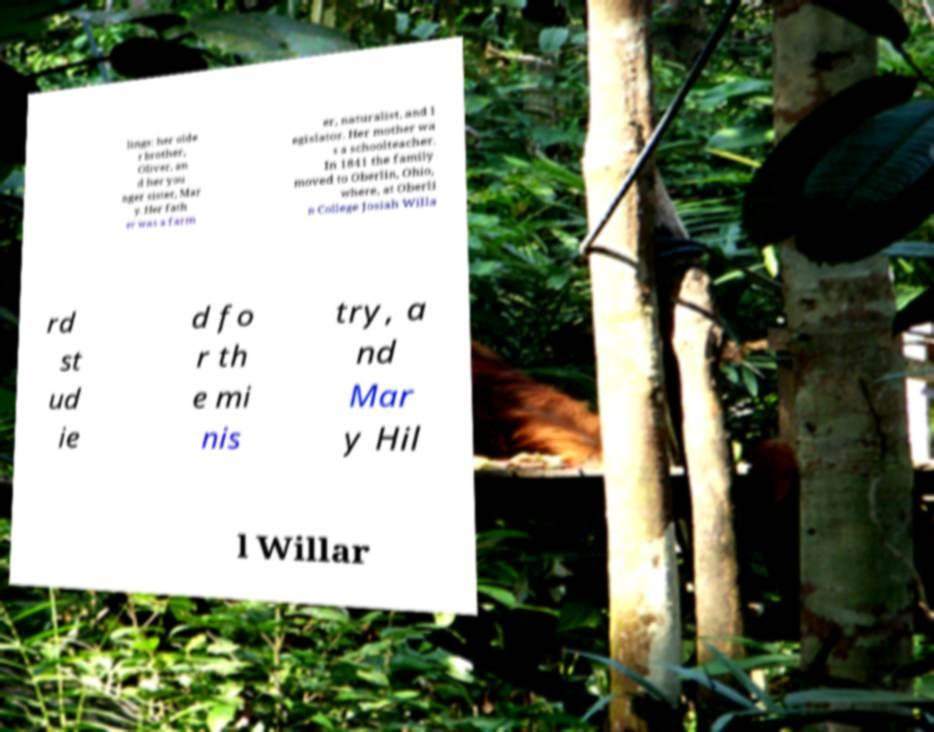I need the written content from this picture converted into text. Can you do that? lings: her olde r brother, Oliver, an d her you nger sister, Mar y. Her fath er was a farm er, naturalist, and l egislator. Her mother wa s a schoolteacher. In 1841 the family moved to Oberlin, Ohio, where, at Oberli n College Josiah Willa rd st ud ie d fo r th e mi nis try, a nd Mar y Hil l Willar 